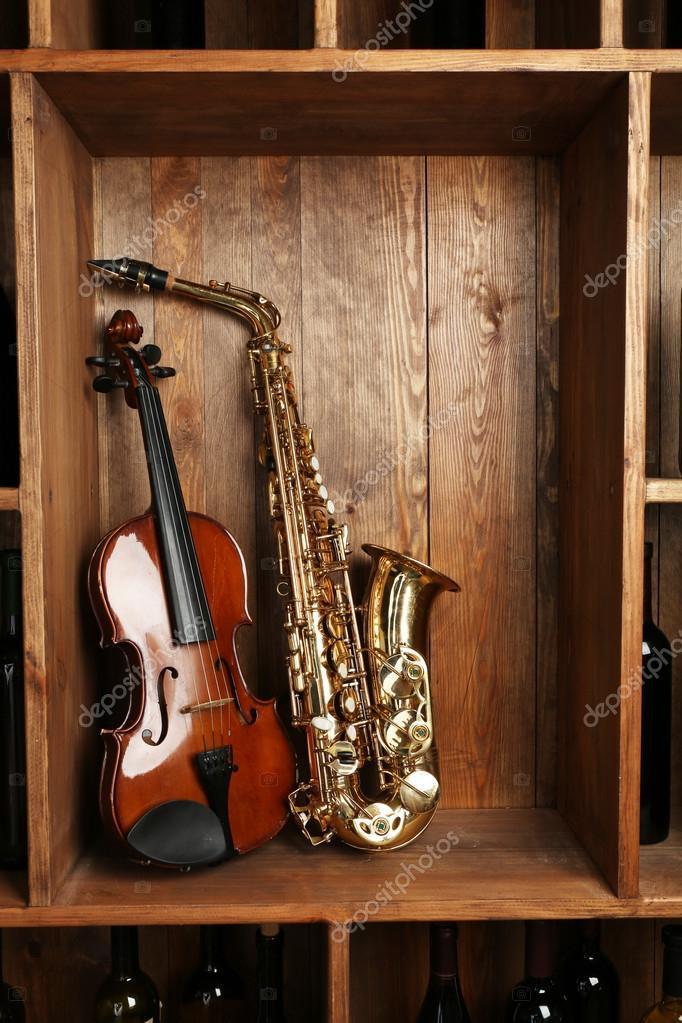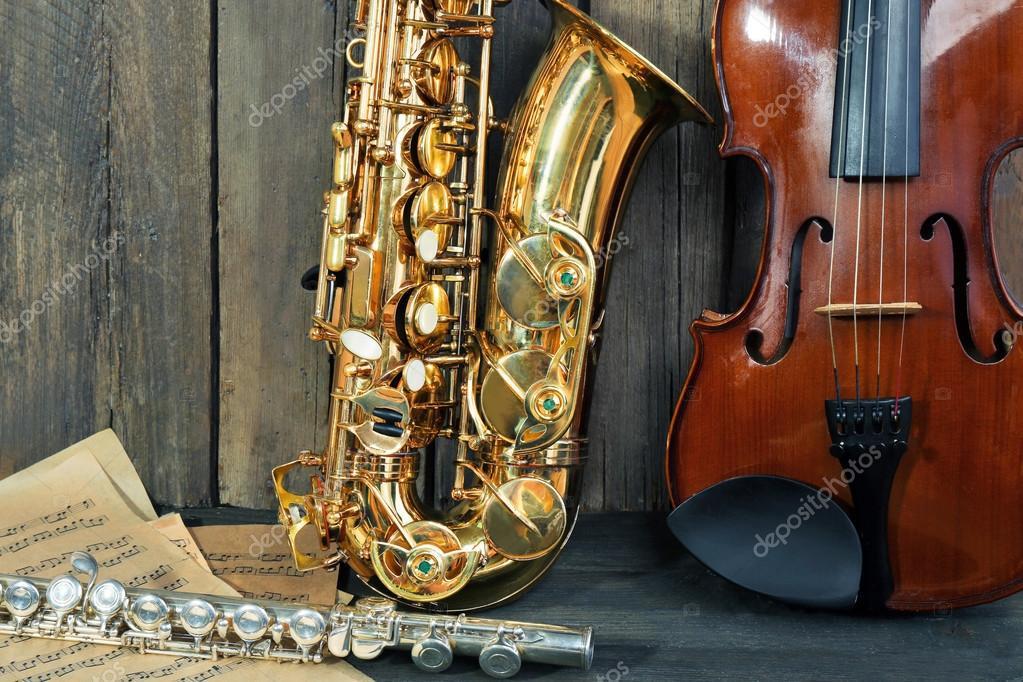The first image is the image on the left, the second image is the image on the right. Analyze the images presented: Is the assertion "A saxophone stands alone in the image on the left." valid? Answer yes or no. No. The first image is the image on the left, the second image is the image on the right. For the images displayed, is the sentence "An image shows a guitar, a gold saxophone, and a silver clarinet, all standing upright side-by-side." factually correct? Answer yes or no. No. 